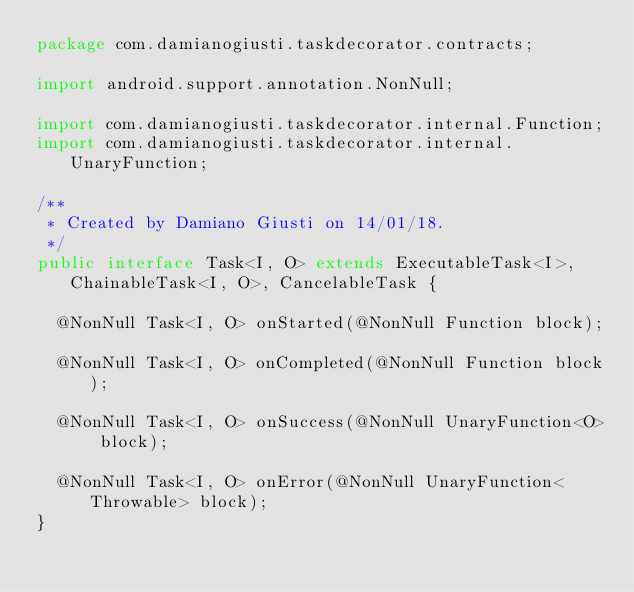Convert code to text. <code><loc_0><loc_0><loc_500><loc_500><_Java_>package com.damianogiusti.taskdecorator.contracts;

import android.support.annotation.NonNull;

import com.damianogiusti.taskdecorator.internal.Function;
import com.damianogiusti.taskdecorator.internal.UnaryFunction;

/**
 * Created by Damiano Giusti on 14/01/18.
 */
public interface Task<I, O> extends ExecutableTask<I>, ChainableTask<I, O>, CancelableTask {

  @NonNull Task<I, O> onStarted(@NonNull Function block);

  @NonNull Task<I, O> onCompleted(@NonNull Function block);

  @NonNull Task<I, O> onSuccess(@NonNull UnaryFunction<O> block);

  @NonNull Task<I, O> onError(@NonNull UnaryFunction<Throwable> block);
}
</code> 